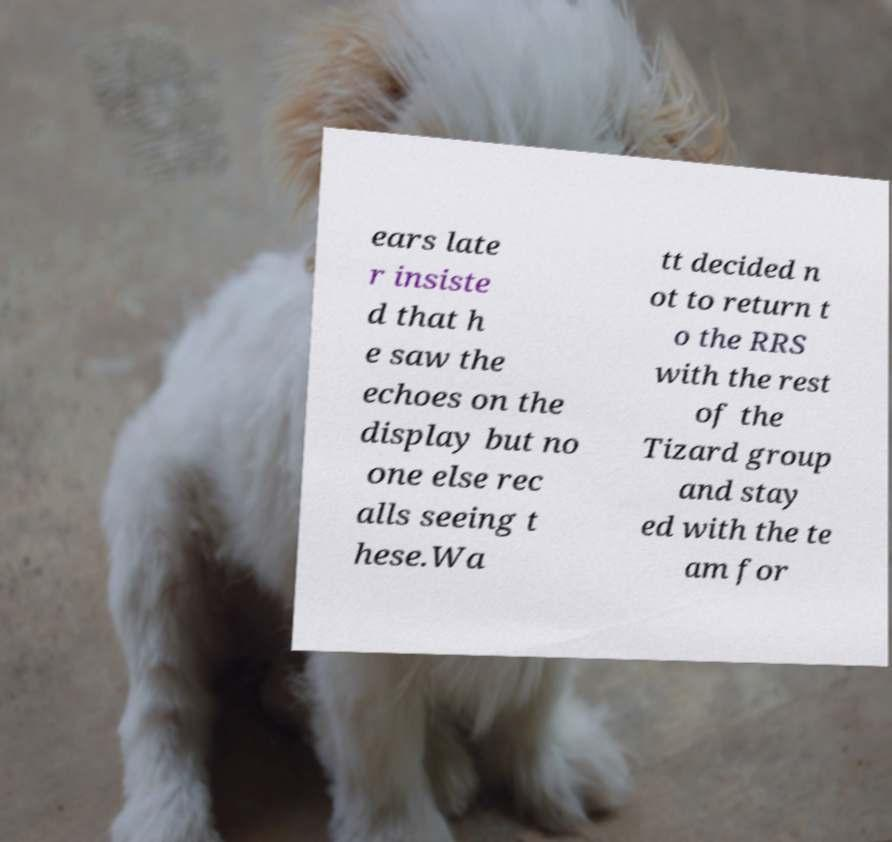Could you extract and type out the text from this image? ears late r insiste d that h e saw the echoes on the display but no one else rec alls seeing t hese.Wa tt decided n ot to return t o the RRS with the rest of the Tizard group and stay ed with the te am for 